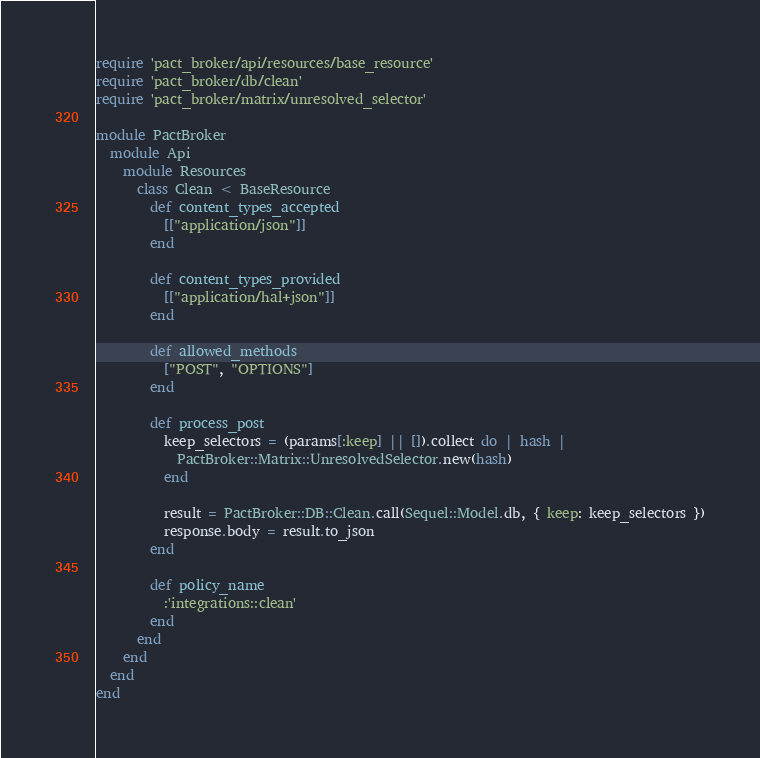<code> <loc_0><loc_0><loc_500><loc_500><_Ruby_>require 'pact_broker/api/resources/base_resource'
require 'pact_broker/db/clean'
require 'pact_broker/matrix/unresolved_selector'

module PactBroker
  module Api
    module Resources
      class Clean < BaseResource
        def content_types_accepted
          [["application/json"]]
        end

        def content_types_provided
          [["application/hal+json"]]
        end

        def allowed_methods
          ["POST", "OPTIONS"]
        end

        def process_post
          keep_selectors = (params[:keep] || []).collect do | hash |
            PactBroker::Matrix::UnresolvedSelector.new(hash)
          end

          result = PactBroker::DB::Clean.call(Sequel::Model.db, { keep: keep_selectors })
          response.body = result.to_json
        end

        def policy_name
          :'integrations::clean'
        end
      end
    end
  end
end
</code> 